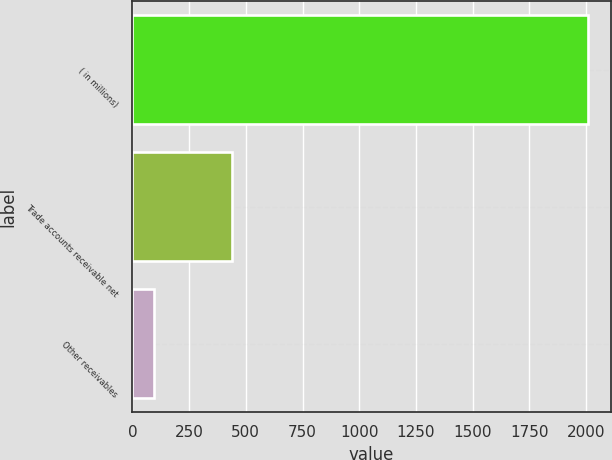Convert chart. <chart><loc_0><loc_0><loc_500><loc_500><bar_chart><fcel>( in millions)<fcel>Trade accounts receivable net<fcel>Other receivables<nl><fcel>2009<fcel>439.9<fcel>95<nl></chart> 